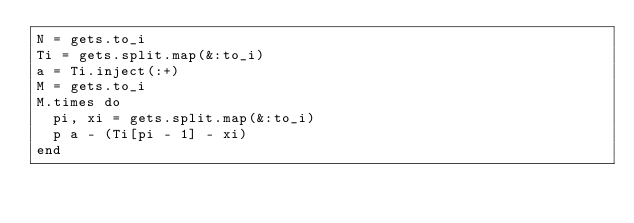Convert code to text. <code><loc_0><loc_0><loc_500><loc_500><_Ruby_>N = gets.to_i
Ti = gets.split.map(&:to_i)
a = Ti.inject(:+)
M = gets.to_i
M.times do
  pi, xi = gets.split.map(&:to_i)
  p a - (Ti[pi - 1] - xi)
end
</code> 